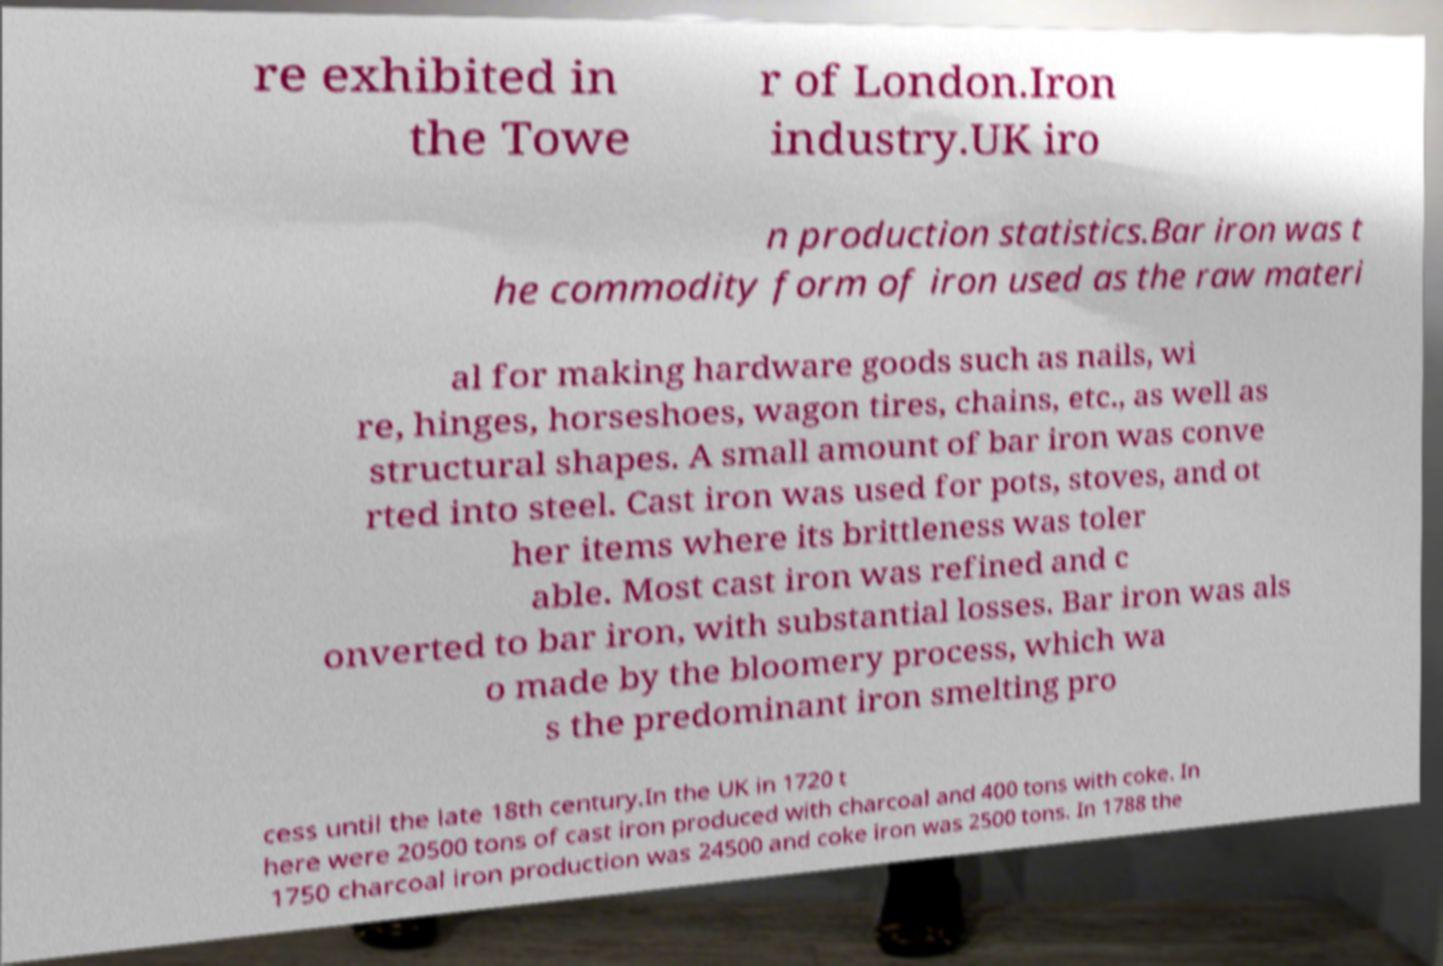Could you assist in decoding the text presented in this image and type it out clearly? re exhibited in the Towe r of London.Iron industry.UK iro n production statistics.Bar iron was t he commodity form of iron used as the raw materi al for making hardware goods such as nails, wi re, hinges, horseshoes, wagon tires, chains, etc., as well as structural shapes. A small amount of bar iron was conve rted into steel. Cast iron was used for pots, stoves, and ot her items where its brittleness was toler able. Most cast iron was refined and c onverted to bar iron, with substantial losses. Bar iron was als o made by the bloomery process, which wa s the predominant iron smelting pro cess until the late 18th century.In the UK in 1720 t here were 20500 tons of cast iron produced with charcoal and 400 tons with coke. In 1750 charcoal iron production was 24500 and coke iron was 2500 tons. In 1788 the 